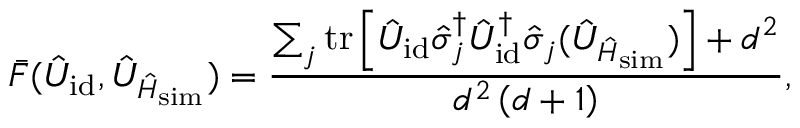Convert formula to latex. <formula><loc_0><loc_0><loc_500><loc_500>\bar { F } ( \hat { U } _ { i d } , \hat { U } _ { \hat { H } _ { s i m } } ) = \frac { \sum _ { j } t r \left [ \hat { U } _ { i d } \hat { \sigma } _ { j } ^ { \dagger } \hat { U } _ { i d } ^ { \dagger } \hat { \sigma } _ { j } ( \hat { U } _ { \hat { H } _ { s i m } } ) \right ] + d ^ { 2 } } { d ^ { 2 } \left ( d + 1 \right ) } ,</formula> 